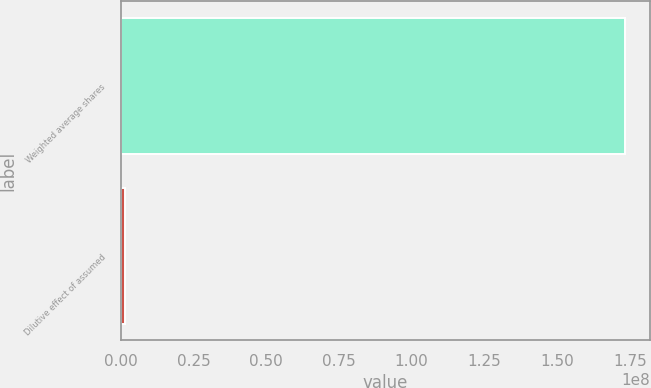Convert chart to OTSL. <chart><loc_0><loc_0><loc_500><loc_500><bar_chart><fcel>Weighted average shares<fcel>Dilutive effect of assumed<nl><fcel>1.73381e+08<fcel>1.553e+06<nl></chart> 